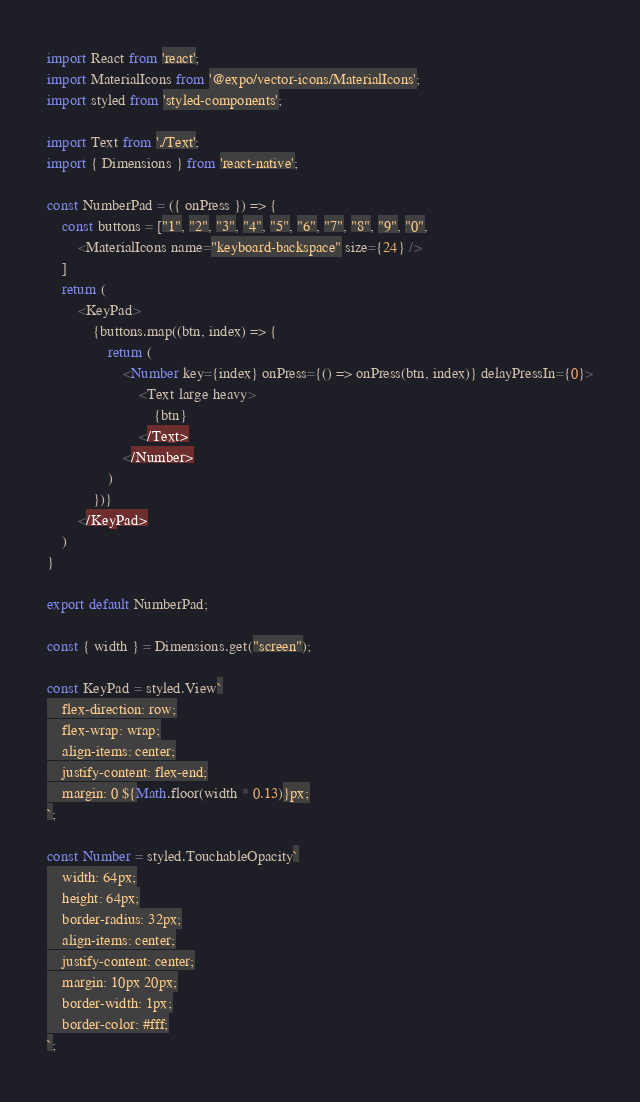Convert code to text. <code><loc_0><loc_0><loc_500><loc_500><_JavaScript_>import React from 'react';
import MaterialIcons from '@expo/vector-icons/MaterialIcons';
import styled from 'styled-components';

import Text from './Text';
import { Dimensions } from 'react-native';

const NumberPad = ({ onPress }) => {
    const buttons = ["1", "2", "3", "4", "5", "6", "7", "8", "9", "0",
        <MaterialIcons name="keyboard-backspace" size={24} />
    ]
    return (
        <KeyPad>
            {buttons.map((btn, index) => {
                return (
                    <Number key={index} onPress={() => onPress(btn, index)} delayPressIn={0}>
                        <Text large heavy>
                            {btn}
                        </Text>
                    </Number>
                )
            })}
        </KeyPad>
    )
}

export default NumberPad;

const { width } = Dimensions.get("screen");

const KeyPad = styled.View`
    flex-direction: row;
    flex-wrap: wrap;
    align-items: center;
    justify-content: flex-end;
    margin: 0 ${Math.floor(width * 0.13)}px;
`;

const Number = styled.TouchableOpacity`
    width: 64px;
    height: 64px;
    border-radius: 32px;
    align-items: center;
    justify-content: center;
    margin: 10px 20px;
    border-width: 1px;
    border-color: #fff;
`;</code> 